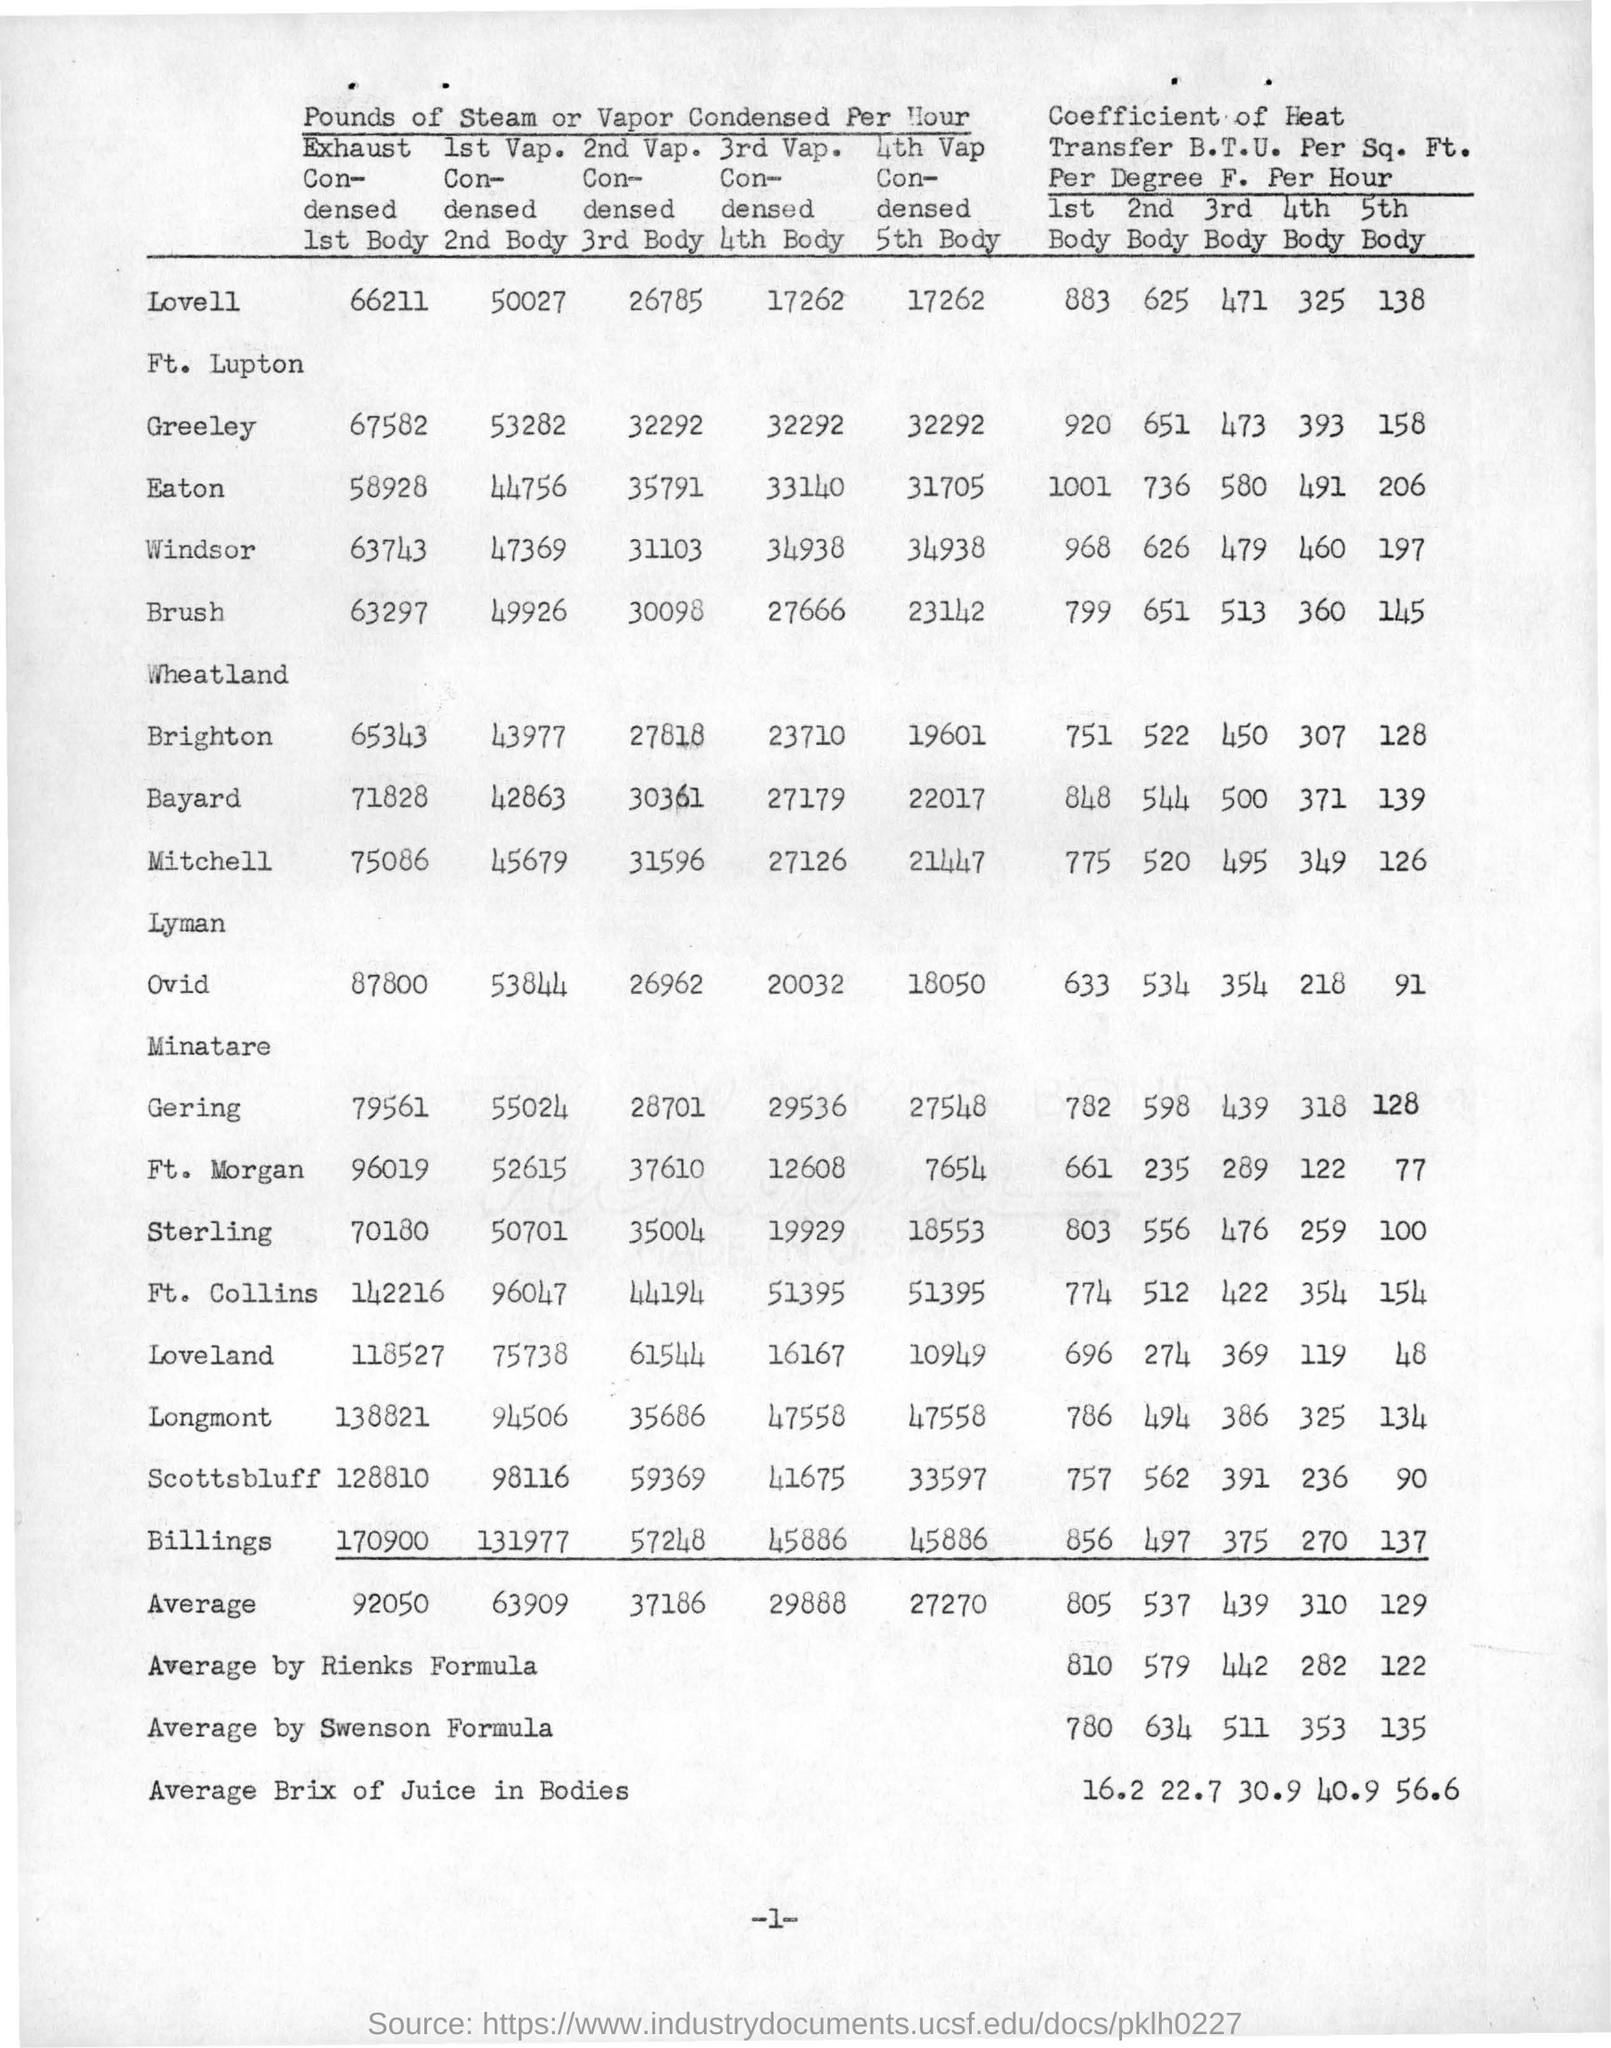Draw attention to some important aspects in this diagram. The coefficient of heat in the first body, using Rink's formula, has a value of 810. The average Brix of juice in bodies for the third body is 30.9. The vapor condensed per hour for Bayard in the second body is 42,863. The coefficient of heat for Eaton in the first body is 1001. The value of the average by Swenson formula for the coefficient of heat in the 5th body is 135. 